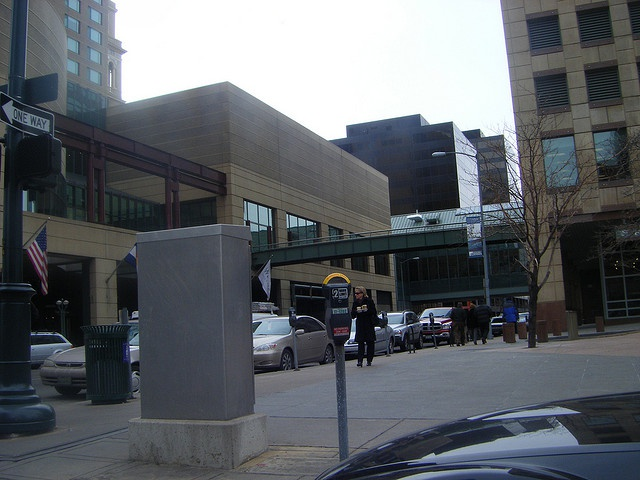Describe the objects in this image and their specific colors. I can see car in gray, black, navy, and darkgray tones, car in gray, black, and darkgray tones, car in gray and black tones, parking meter in gray, black, and maroon tones, and people in gray, black, and maroon tones in this image. 